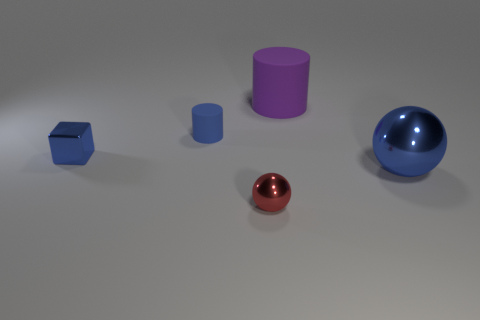There is a large blue thing; does it have the same shape as the matte thing that is to the left of the large rubber object?
Your answer should be very brief. No. What is the tiny red ball made of?
Ensure brevity in your answer.  Metal. There is another purple matte object that is the same shape as the tiny matte thing; what size is it?
Offer a very short reply. Large. What number of other things are made of the same material as the red ball?
Provide a succinct answer. 2. Do the blue block and the sphere that is on the left side of the purple cylinder have the same material?
Your answer should be compact. Yes. Is the number of purple cylinders that are to the right of the purple matte cylinder less than the number of matte cylinders that are behind the blue cylinder?
Keep it short and to the point. Yes. What color is the thing on the right side of the big rubber object?
Provide a succinct answer. Blue. What number of other things are the same color as the small block?
Offer a terse response. 2. Does the blue metallic object in front of the block have the same size as the red sphere?
Your answer should be compact. No. There is a small blue cube; what number of blue shiny objects are behind it?
Make the answer very short. 0. 